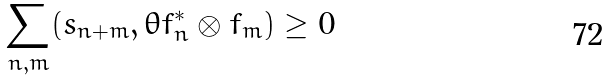<formula> <loc_0><loc_0><loc_500><loc_500>\sum _ { n , m } ( s _ { n + m } , \theta f _ { n } ^ { \ast } \otimes f _ { m } ) \geq 0</formula> 